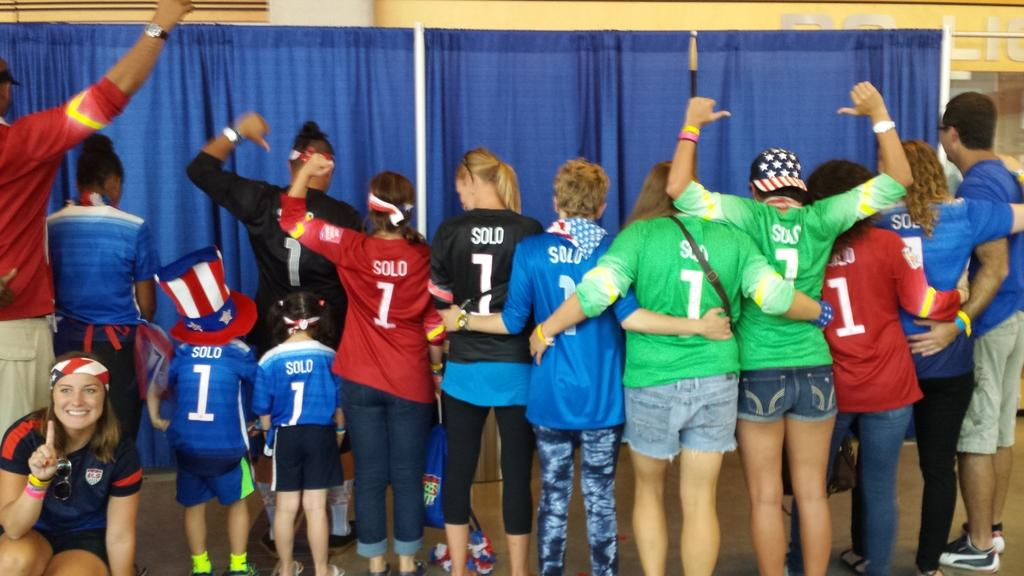<image>
Offer a succinct explanation of the picture presented. A group of people with Jerseys that have the number one 